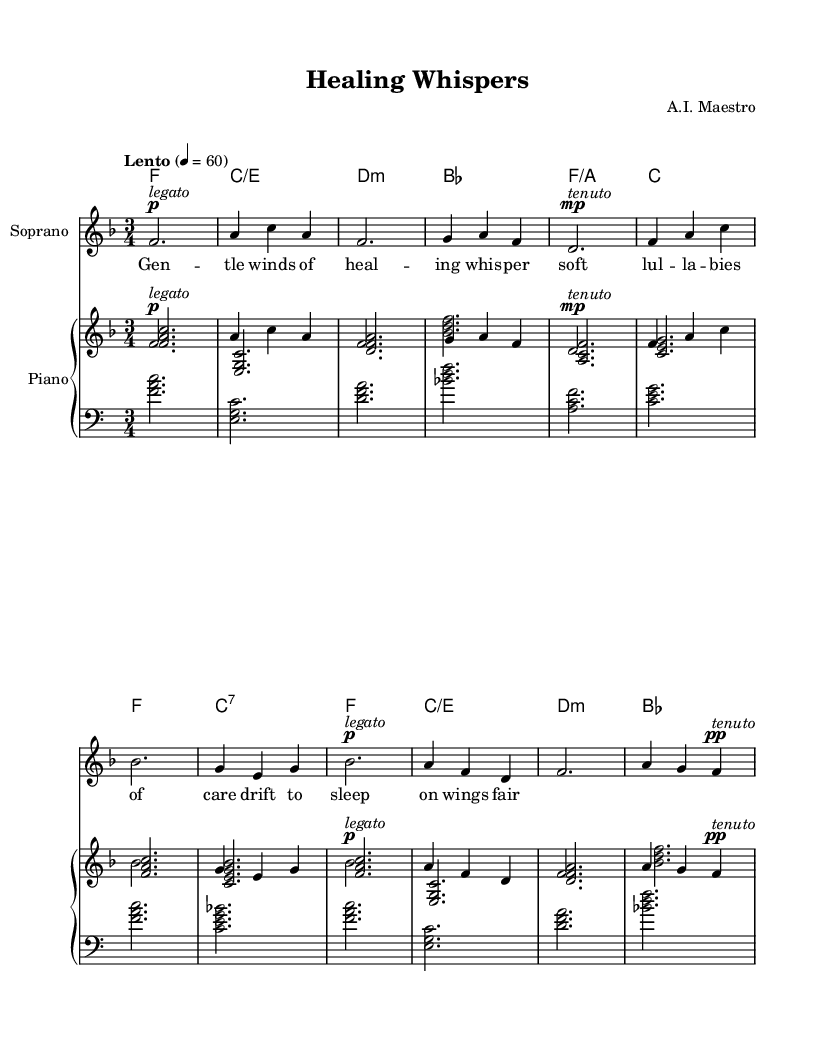What is the key signature of this music? The key signature is F major, which has one flat (B flat). This is indicated at the beginning of the staff, where the flat sign is placed on the B line.
Answer: F major What is the time signature of this piece? The time signature shown at the beginning is 3/4, which indicates that there are three beats in each measure and a quarter note gets one beat. This is clearly represented in the notation near the start.
Answer: 3/4 What is the tempo marking for this lullaby? The tempo marking indicates "Lento," which means slow. The numerical indication of 4 = 60 specifies that there are 60 beats per minute. This information is given in the tempo marking at the beginning of the score.
Answer: Lento How many measures does the piece contain? The piece contains 8 measures. This can be determined by counting the number of vertical lines (bar lines) between the beginning and end of the score, which separate the music into distinct measures.
Answer: 8 What is the dynamic marking for the final note of the melody? The final note of the melody is marked with a "pp," which indicates "pianissimo," meaning very soft. This is shown right above the last note in the melody.
Answer: pianissimo What does the lyric "gentle winds of healing whisper soft" communicate about the theme? The lyric suggests a soothing and comforting theme, focusing on healing and relaxation, which aligns with the purpose of the lullaby in providing comfort to patients. This is intrinsic to the text of the lullaby itself.
Answer: Soothing What is the instrument name for the lower staff in the score? The lower staff is labeled "Piano" indicating that it is designed for piano accompaniment. The instrument name is represented clearly at the beginning of the staff.
Answer: Piano 